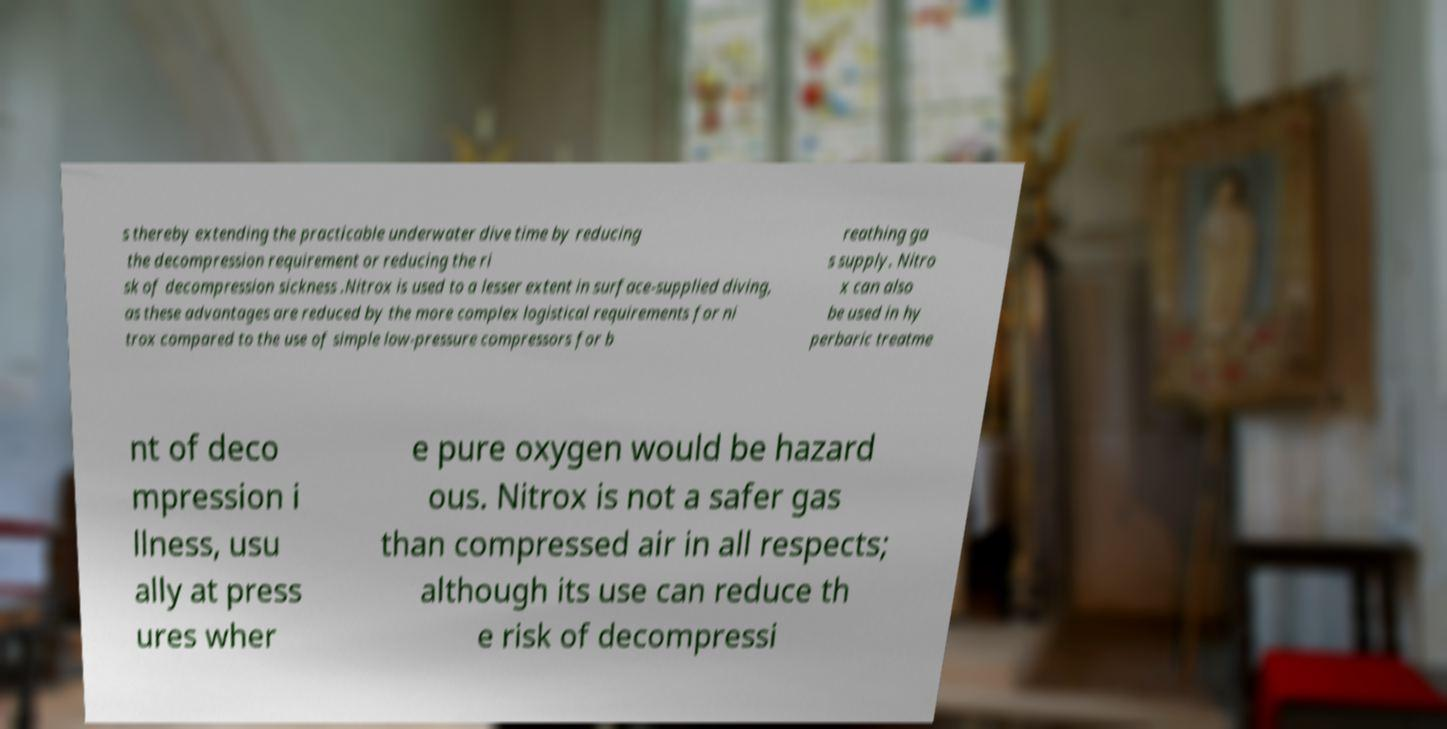For documentation purposes, I need the text within this image transcribed. Could you provide that? s thereby extending the practicable underwater dive time by reducing the decompression requirement or reducing the ri sk of decompression sickness .Nitrox is used to a lesser extent in surface-supplied diving, as these advantages are reduced by the more complex logistical requirements for ni trox compared to the use of simple low-pressure compressors for b reathing ga s supply. Nitro x can also be used in hy perbaric treatme nt of deco mpression i llness, usu ally at press ures wher e pure oxygen would be hazard ous. Nitrox is not a safer gas than compressed air in all respects; although its use can reduce th e risk of decompressi 